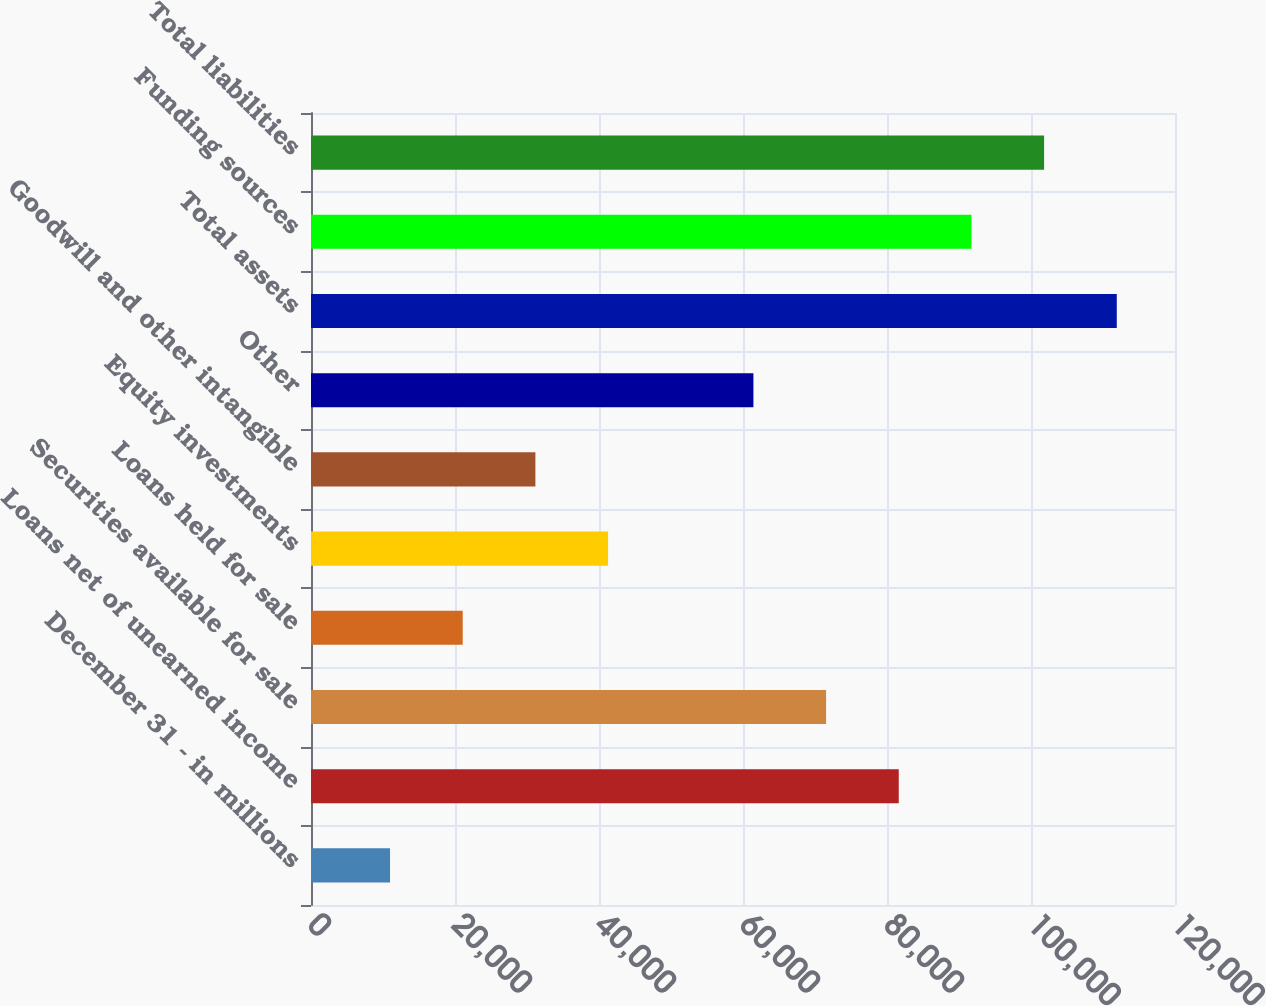Convert chart. <chart><loc_0><loc_0><loc_500><loc_500><bar_chart><fcel>December 31 - in millions<fcel>Loans net of unearned income<fcel>Securities available for sale<fcel>Loans held for sale<fcel>Equity investments<fcel>Goodwill and other intangible<fcel>Other<fcel>Total assets<fcel>Funding sources<fcel>Total liabilities<nl><fcel>10978.5<fcel>81633<fcel>71539.5<fcel>21072<fcel>41259<fcel>31165.5<fcel>61446<fcel>111914<fcel>91726.5<fcel>101820<nl></chart> 